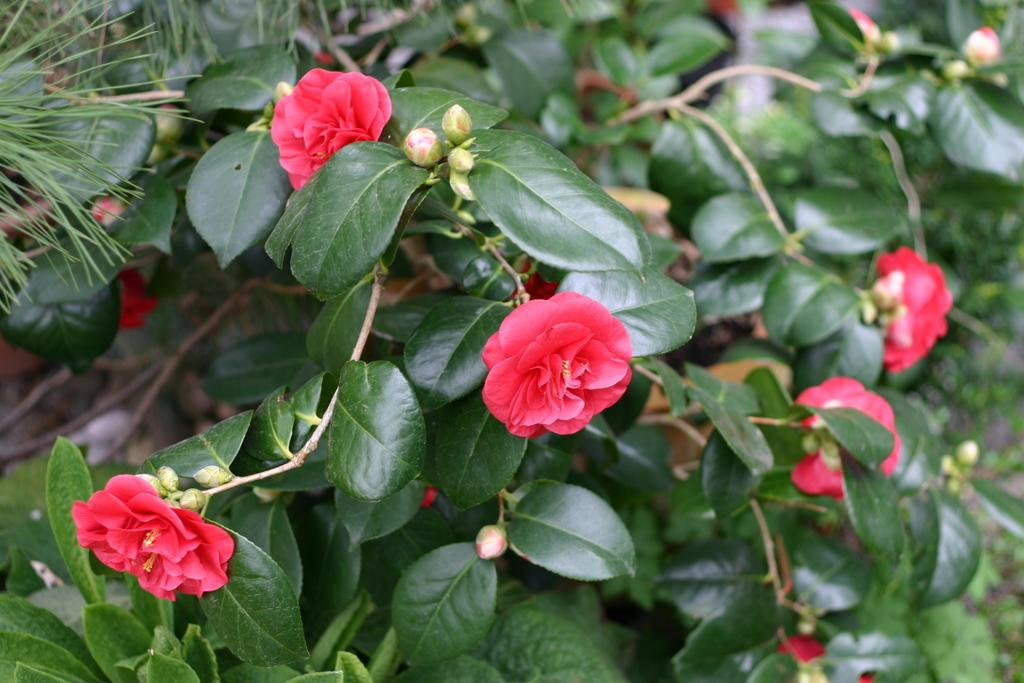What type of plants can be seen in the image? There are plants with flowers in the image. How are the plants arranged or contained in the image? The plants are in pots. What color are the flowers on the plants? The flowers are red in color. What is the condition of the mine in the image? There is no mine present in the image; it features plants with red flowers in pots. 